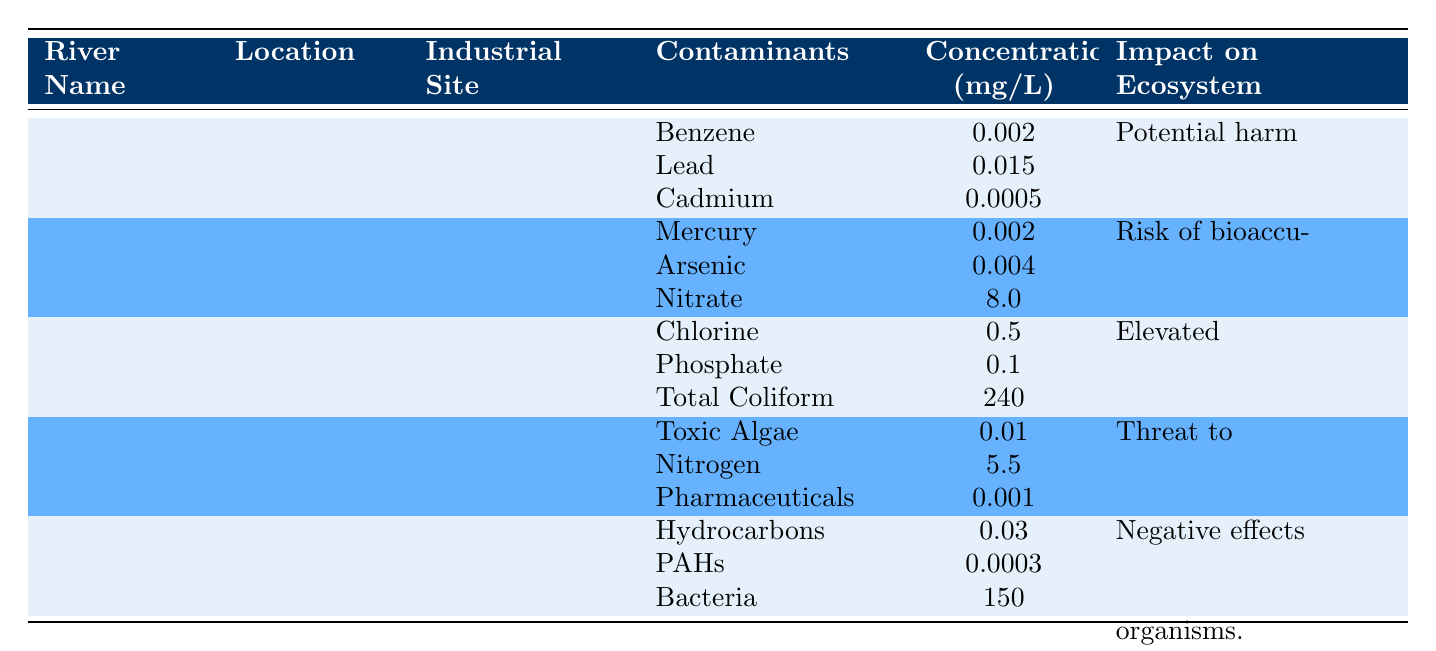What is the contaminant concentration level for Nitrate in the Ohio River? Referring to the table under the Ohio River section, the concentration of Nitrate is noted as 8.0 mg/L.
Answer: 8.0 mg/L Which industrial site is associated with the Potomac River? The table specifies that the industrial site for the Potomac River is Washington Gas Energy Services.
Answer: Washington Gas Energy Services Is the concentration of Chlorine in the Potomac River greater than 0.5 mg/L? The table indicates that Chlorine concentration in the Potomac River is exactly 0.5 mg/L, so it is not greater.
Answer: No What is the total concentration of harmful contaminants in Sarasota Bay? The total contaminant concentrations are: Toxic Algae (0.01 mg/L) + Nitrogen (5.5 mg/L) + Pharmaceuticals (0.001 mg/L) = 5.511 mg/L.
Answer: 5.511 mg/L What is the main impact on the ecosystem for the Mississippi River? The table states that the impact on the ecosystem for the Mississippi River is "Potential harm to aquatic life and drinking water sources."
Answer: Potential harm to aquatic life and drinking water sources Which river has the highest concentration level of contaminants, and what is it? Comparing the contaminants listed, the Potomac River has a Total Coliform concentration of 240 mg/L, which is significantly higher than others listed.
Answer: Potomac River, 240 mg/L Is there any contaminants listed for the San Francisco Bay that are hydrocarbons? The table shows Hydrocarbons listed as a contaminant for the San Francisco Bay.
Answer: Yes Which river shows a risk of bioaccumulation in fish species, and what contaminants are involved? The Ohio River is linked to the risk of bioaccumulation, with Mercury, Arsenic, and Nitrate as contaminants.
Answer: Ohio River; Mercury, Arsenic, Nitrate 